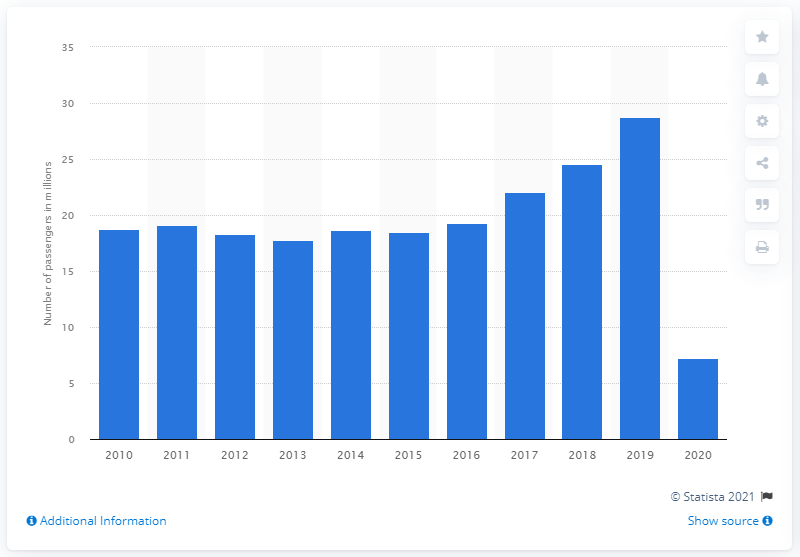Indicate a few pertinent items in this graphic. In 2019, 28,710 passengers traveled through Milan Malpensa Airport. In 2020, there were 7,200 passengers traveling through Milan Malpensa Airport. 